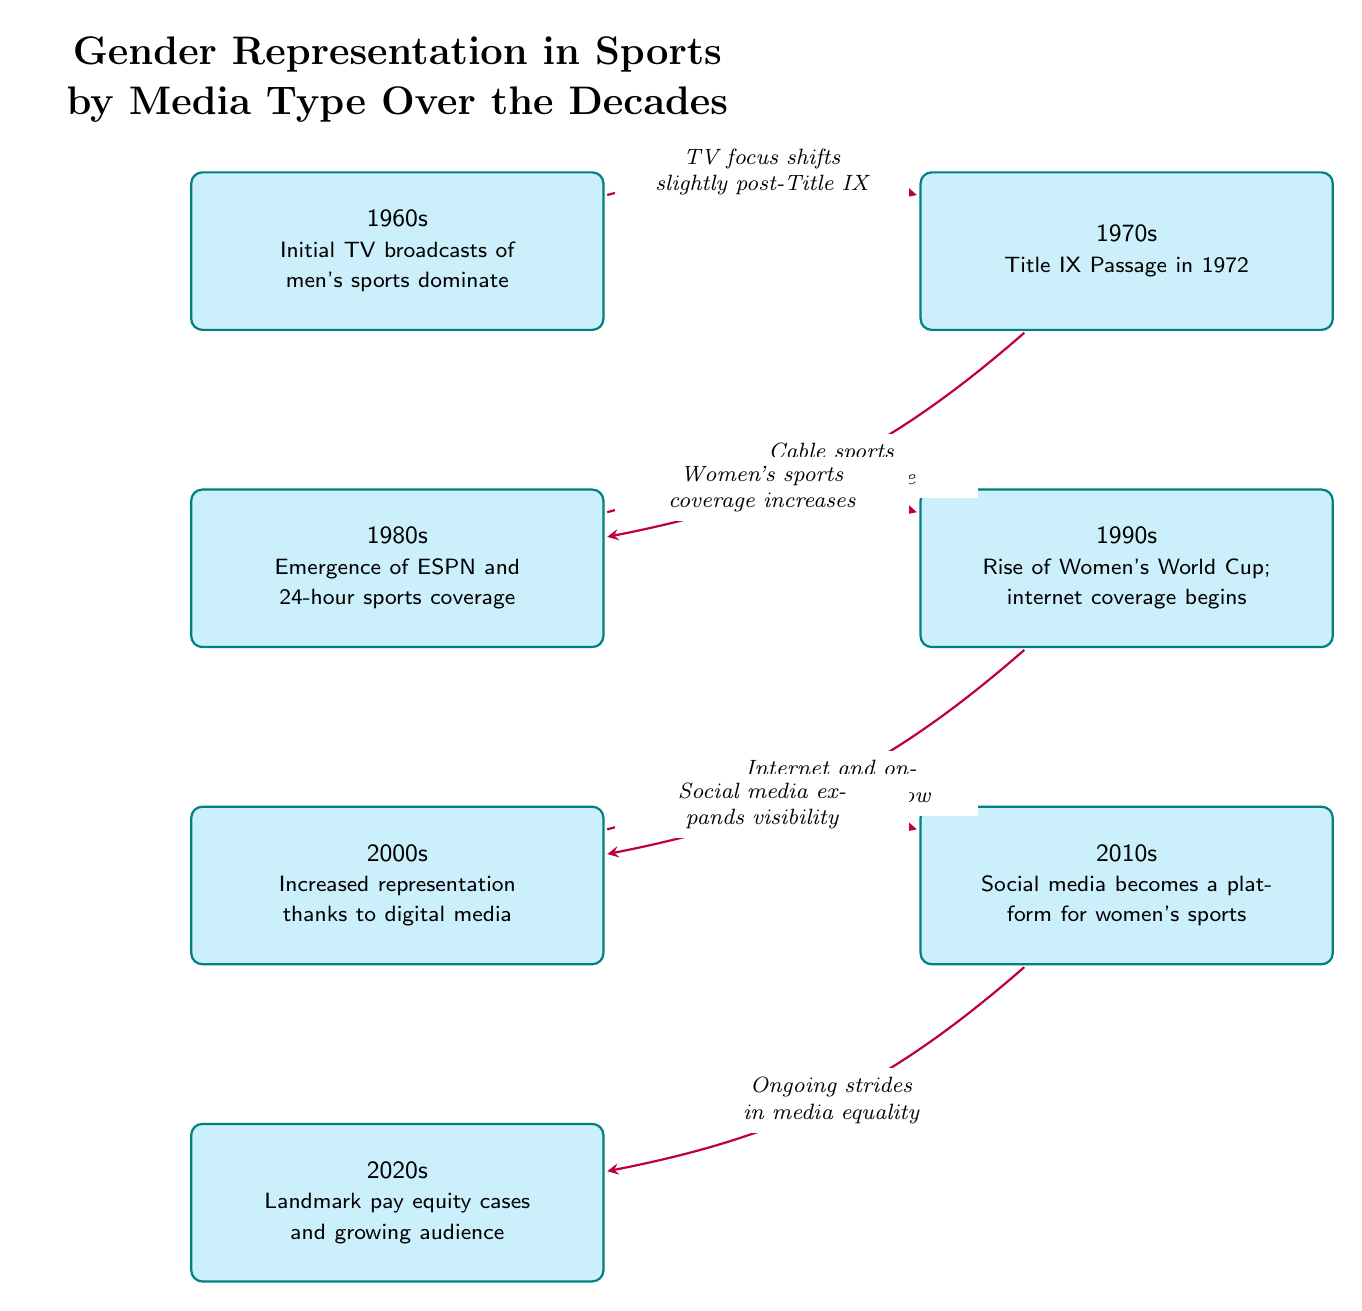What decade saw the passage of Title IX? Title IX was passed in 1972, which falls within the 1970s decade as depicted in the diagram.
Answer: 1970s How many nodes represent milestones related to women's sports? There are seven milestones listed in the diagram, starting from the 1960s up to the 2020s.
Answer: 7 What was a significant milestone in the 1980s? The emergence of ESPN and 24-hour sports coverage is highlighted as the important event for the 1980s in the diagram.
Answer: Emergence of ESPN What type of media coverage increased representation in the 2000s? The diagram indicates that digital media played a significant role in increasing representation during the 2000s.
Answer: Digital media What key development occurred in the 2010s regarding women's sports? The growth of social media as a platform for women's sports is identified as a critical development in the 2010s.
Answer: Social media Which decade marks the start of women’s sports coverage increase according to the diagram? The diagram shows that the increase in women’s sports coverage began in the 1990s, following the rise of the Women’s World Cup and internet coverage.
Answer: 1990s How does the flow from the 1970s to the 1980s depict the impact of Title IX? The diagram indicates a shift in media focus with the arrow connecting the 1970s to the 1980s, emphasizing that post-Title IX, there was a gradual change leading to the emergence of specialized sports networks.
Answer: TV focus shifts slightly post-Title IX What does the diagram highlight as an ongoing trend from the 2010s to the 2020s? The ongoing strides in media equality are highlighted as a significant trend moving from the 2010s into the 2020s.
Answer: Ongoing strides in media equality 